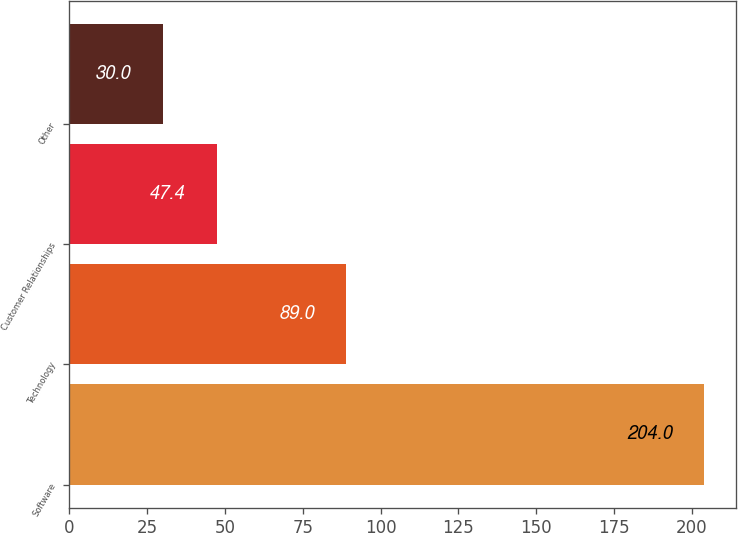Convert chart. <chart><loc_0><loc_0><loc_500><loc_500><bar_chart><fcel>Software<fcel>Technology<fcel>Customer Relationships<fcel>Other<nl><fcel>204<fcel>89<fcel>47.4<fcel>30<nl></chart> 